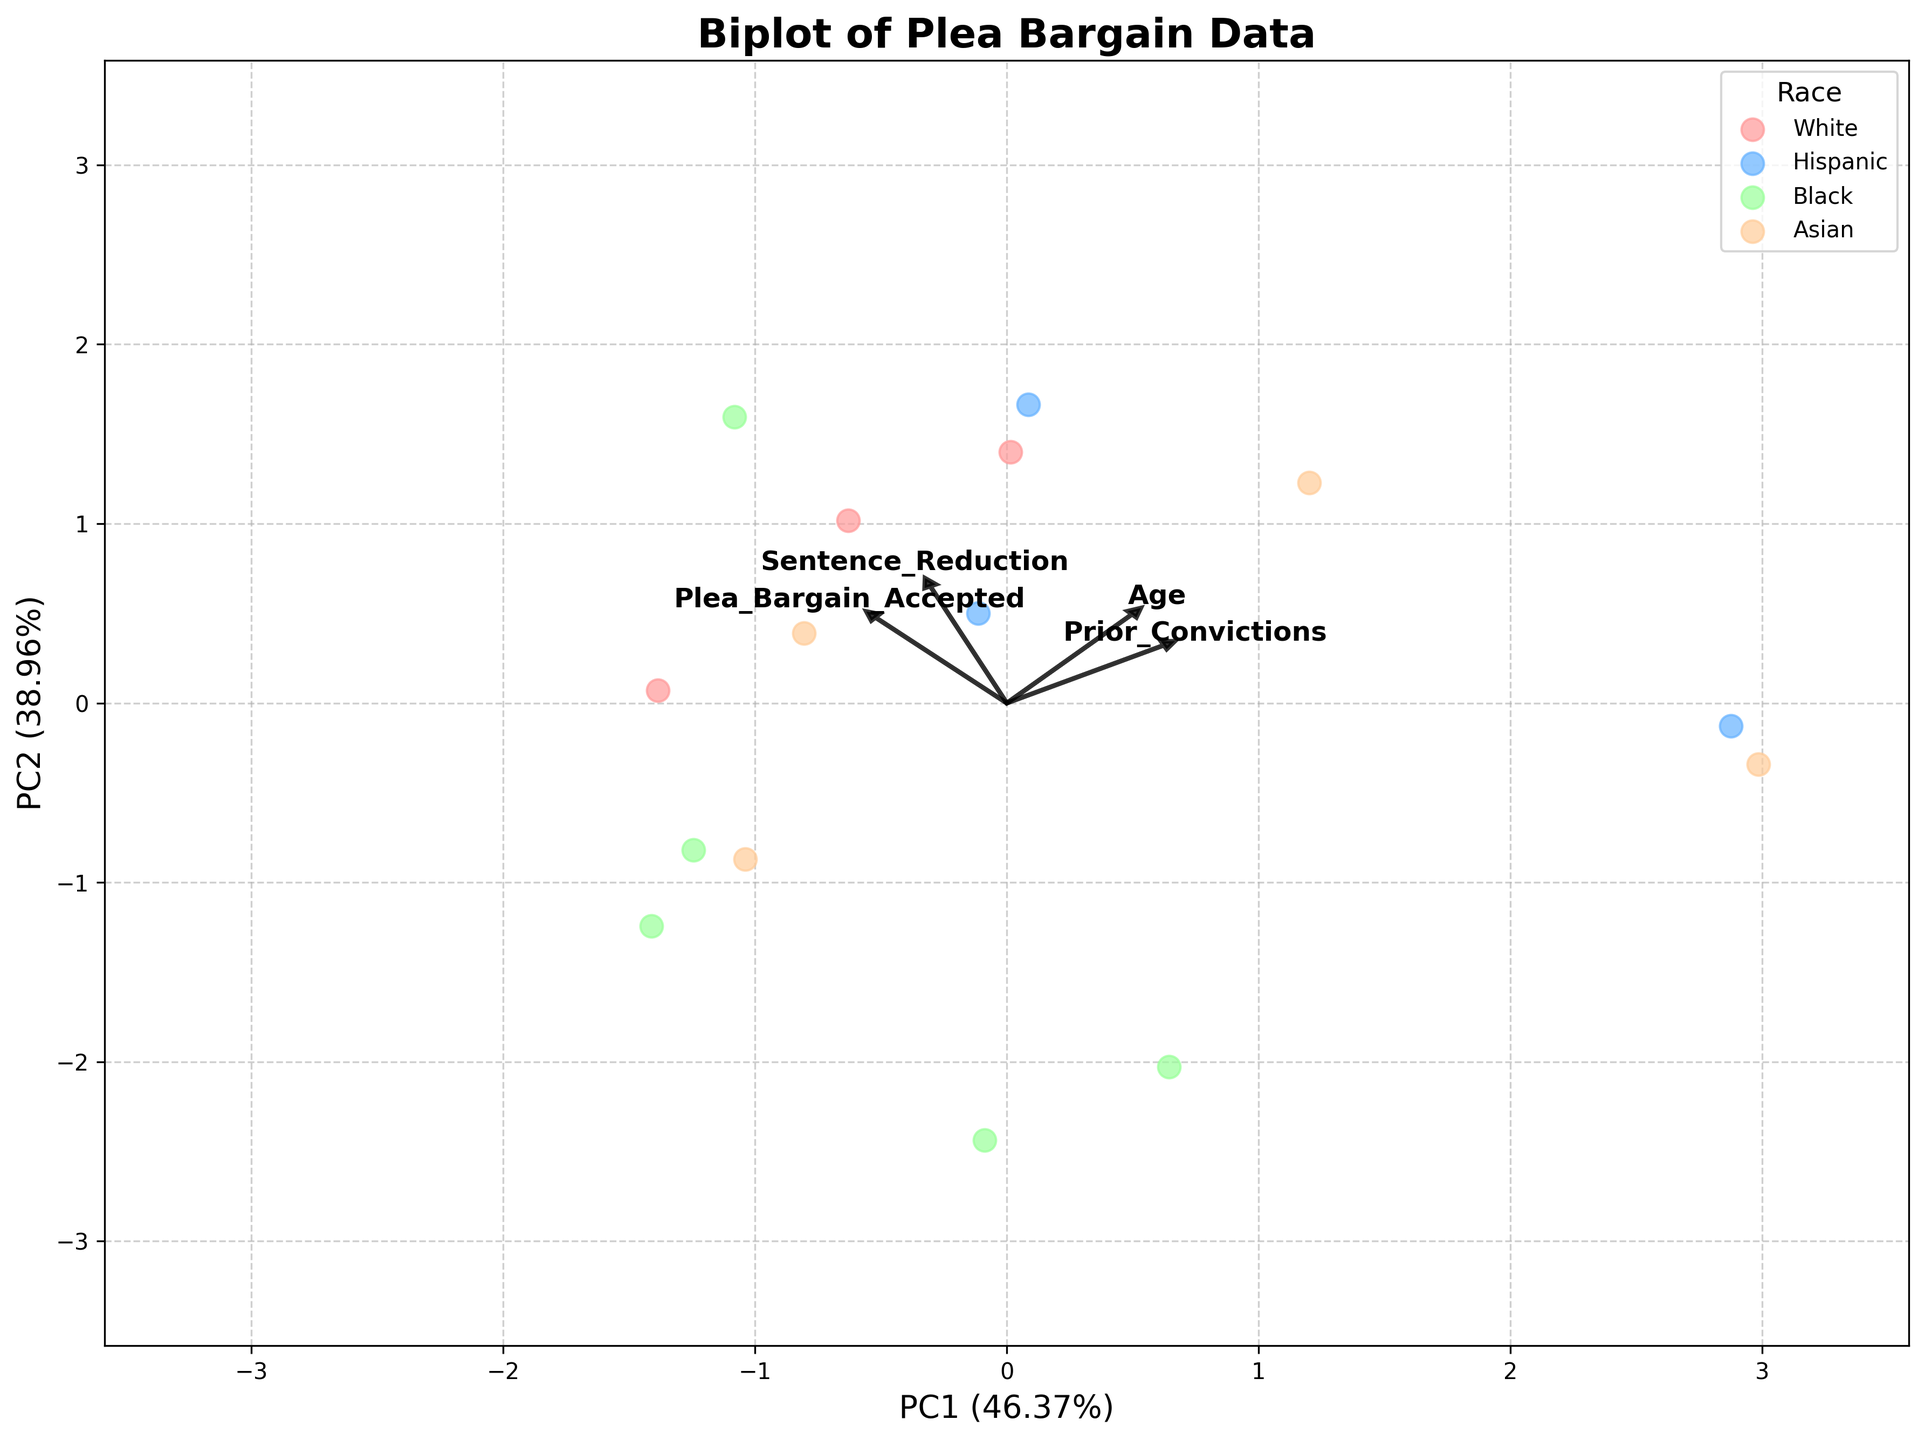How many racial groups are represented in the plot? The legend in the plot shows different colors representing racial groups. Count the number of distinct racial groups mentioned in the legend.
Answer: 4 What is the title of the plot? The title of the plot is found at the top center of the figure.
Answer: Biplot of Plea Bargain Data How are the features 'Age' and 'Prior_Convictions' represented in the plot? These features are represented as arrows pointing from the origin. Each arrow indicates the direction and magnitude of the feature's contribution to the principal components.
Answer: Arrows Which racial group has the data points closest to the origin? Look at the scatter of points and identify the racial group whose points are closest to (0,0). These data points appear to be clustered around the origin.
Answer: White Which feature seems to have the greatest influence on PC1? Observe the arrows and their lengths along the x-axis (PC1). The arrow that extends the farthest in the x-direction indicates the feature with the greatest influence on PC1.
Answer: Sentence_Reduction Which racial group shows the highest plea bargain acceptance rate? The color coding in the legend represents racial groups. Plea bargain acceptance is one of the features. Identify the racial group with the most data points aligned with the direction of the Plea_Bargain_Accepted feature arrow.
Answer: Asian How does 'Sentence_Reduction' correlate with 'Plea_Bargain_Accepted'? Observe the direction and proximity of 'Sentence_Reduction' and 'Plea_Bargain_Accepted' arrows. Features pointing in a similar direction indicate a positive correlation.
Answer: Positively Which two racial groups appear to have the most separation along PC2? Look at the distribution of data points along the y-axis (PC2) and identify the two racial groups that are the farthest apart vertically.
Answer: Black and Hispanic What's the combined percentage of variance explained by PC1 and PC2? The x and y axis labels show the percentage of variance explained by PC1 and PC2. Add these percentages to find the combined variance.
Answer: 67.3% Among the racial groups, which one has the most diverse spread across both principal components? Observe the spread (distribution) of each racial group's data points across the two axes. Identify the racial group with the widest spread.
Answer: Black 